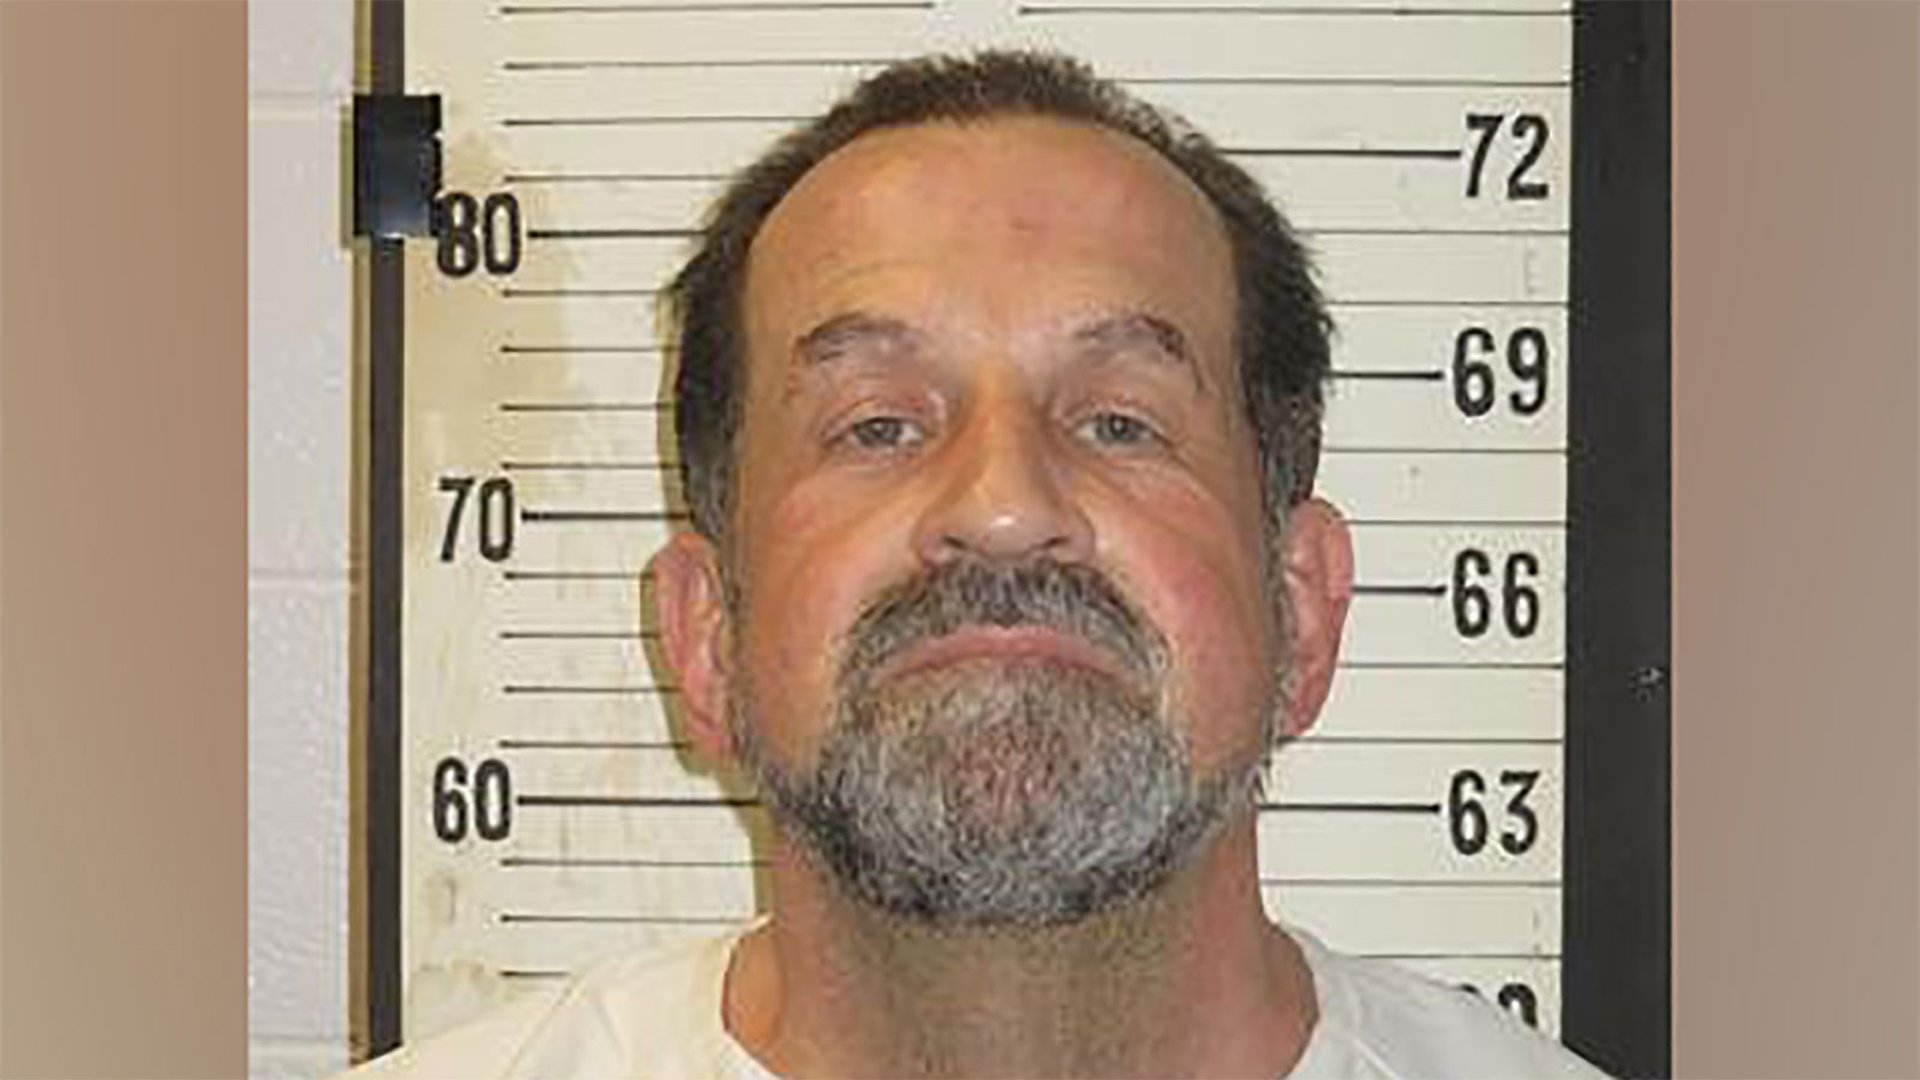If the man were to wear a hat, how much extra height would the hat contribute in centimeters? It depends on the type of hat the man is wearing. For instance, if he wears a standard baseball cap, it might add about 10 centimeters to his height. If it's a taller hat like a top hat, it could contribute up to 20 centimeters or more. 